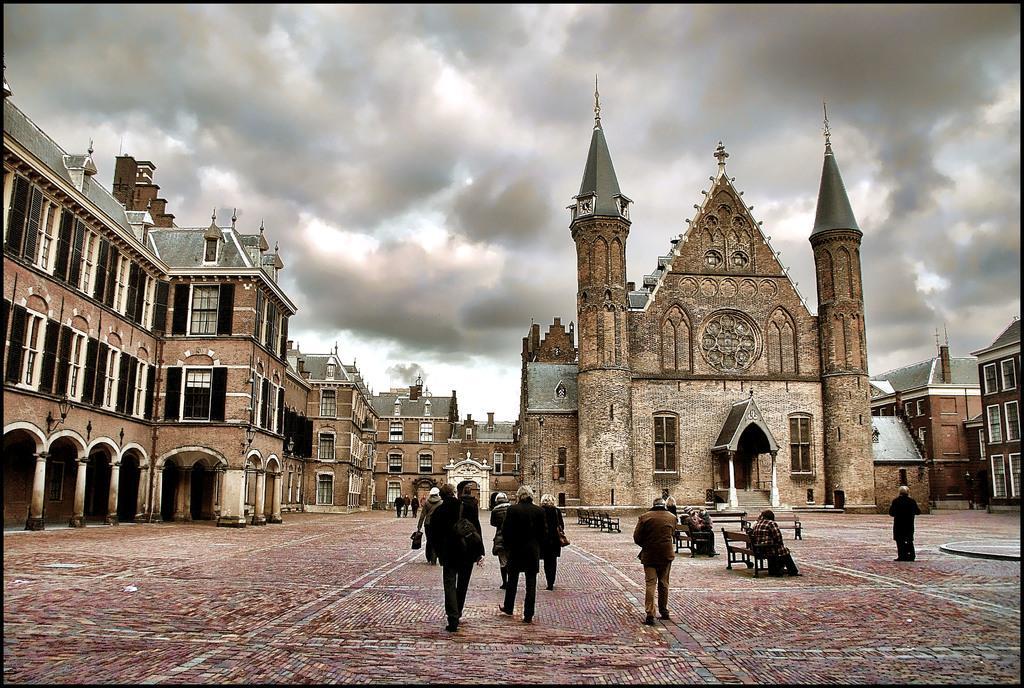Please provide a concise description of this image. In this picture we can see a group of people on the ground, some people are sitting on benches and in the background we can see buildings, sky. 